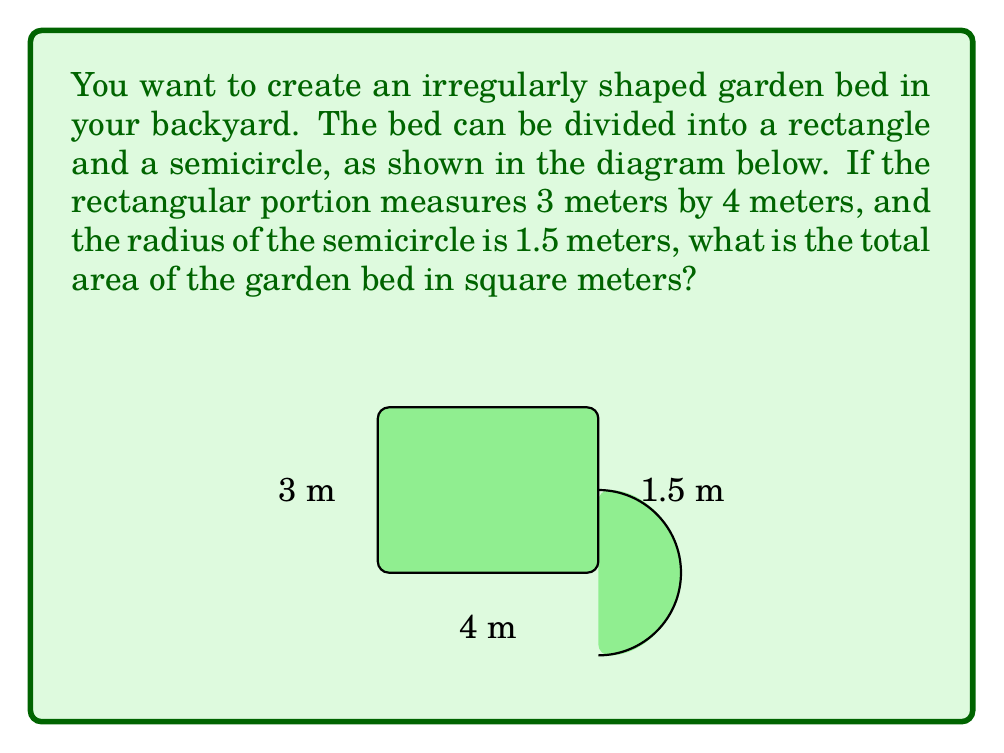Provide a solution to this math problem. To calculate the total area of the irregularly shaped garden bed, we need to:
1. Calculate the area of the rectangular portion
2. Calculate the area of the semicircular portion
3. Add these two areas together

Step 1: Area of the rectangle
$$ A_{rectangle} = length \times width = 4 \text{ m} \times 3 \text{ m} = 12 \text{ m}^2 $$

Step 2: Area of the semicircle
The area of a full circle is $\pi r^2$, so the area of a semicircle is half of that:
$$ A_{semicircle} = \frac{1}{2} \pi r^2 = \frac{1}{2} \pi (1.5 \text{ m})^2 = \frac{9\pi}{4} \text{ m}^2 \approx 7.07 \text{ m}^2 $$

Step 3: Total area
$$ A_{total} = A_{rectangle} + A_{semicircle} = 12 \text{ m}^2 + \frac{9\pi}{4} \text{ m}^2 $$

$$ A_{total} = 12 + \frac{9\pi}{4} \text{ m}^2 \approx 19.07 \text{ m}^2 $$
Answer: $12 + \frac{9\pi}{4} \text{ m}^2$ or approximately $19.07 \text{ m}^2$ 